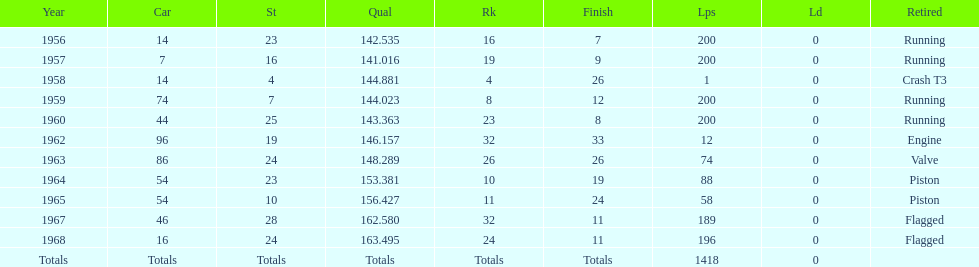Which year is the last qual on the chart 1968. 